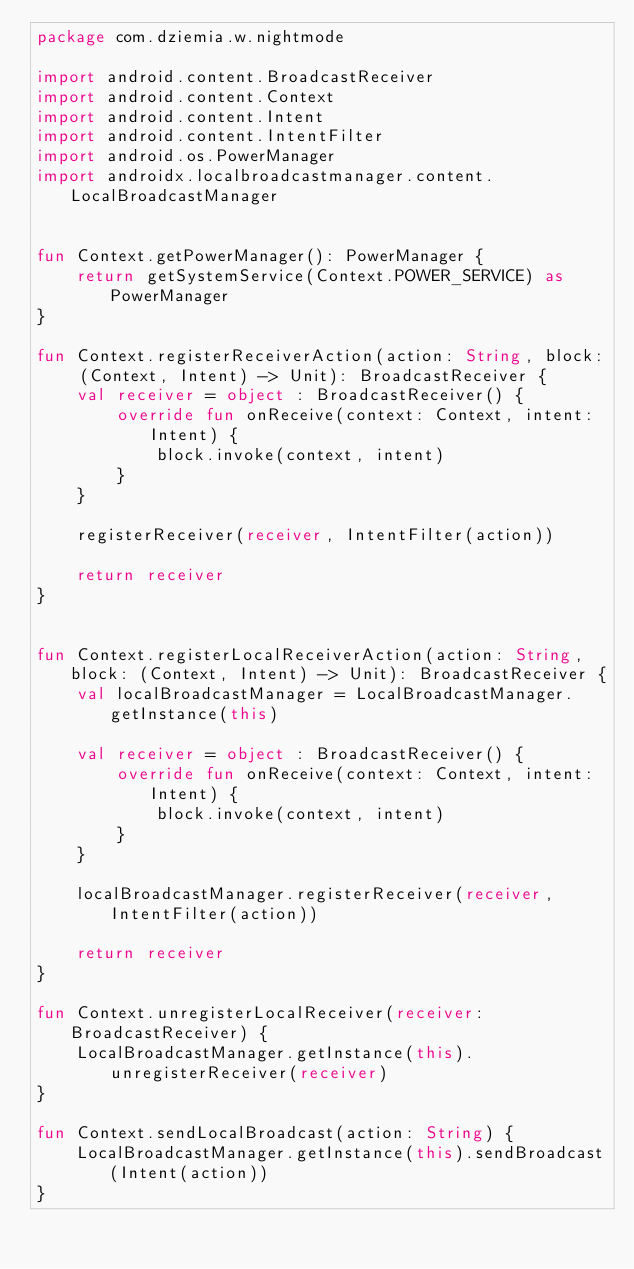<code> <loc_0><loc_0><loc_500><loc_500><_Kotlin_>package com.dziemia.w.nightmode

import android.content.BroadcastReceiver
import android.content.Context
import android.content.Intent
import android.content.IntentFilter
import android.os.PowerManager
import androidx.localbroadcastmanager.content.LocalBroadcastManager


fun Context.getPowerManager(): PowerManager {
    return getSystemService(Context.POWER_SERVICE) as PowerManager
}

fun Context.registerReceiverAction(action: String, block: (Context, Intent) -> Unit): BroadcastReceiver {
    val receiver = object : BroadcastReceiver() {
        override fun onReceive(context: Context, intent: Intent) {
            block.invoke(context, intent)
        }
    }

    registerReceiver(receiver, IntentFilter(action))

    return receiver
}


fun Context.registerLocalReceiverAction(action: String, block: (Context, Intent) -> Unit): BroadcastReceiver {
    val localBroadcastManager = LocalBroadcastManager.getInstance(this)

    val receiver = object : BroadcastReceiver() {
        override fun onReceive(context: Context, intent: Intent) {
            block.invoke(context, intent)
        }
    }

    localBroadcastManager.registerReceiver(receiver, IntentFilter(action))

    return receiver
}

fun Context.unregisterLocalReceiver(receiver: BroadcastReceiver) {
    LocalBroadcastManager.getInstance(this).unregisterReceiver(receiver)
}

fun Context.sendLocalBroadcast(action: String) {
    LocalBroadcastManager.getInstance(this).sendBroadcast(Intent(action))
}
</code> 